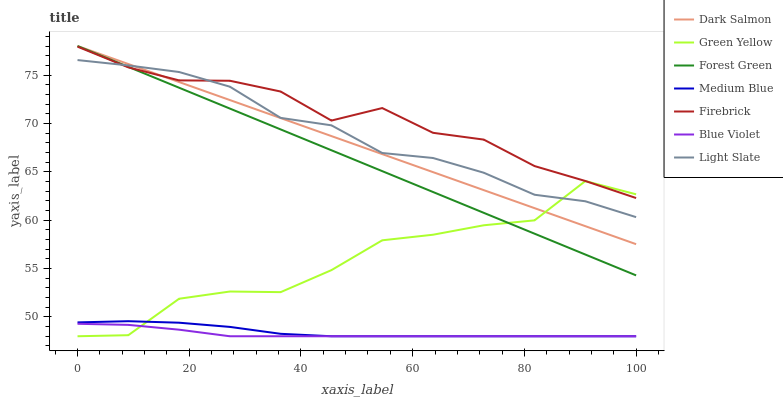Does Blue Violet have the minimum area under the curve?
Answer yes or no. Yes. Does Firebrick have the maximum area under the curve?
Answer yes or no. Yes. Does Medium Blue have the minimum area under the curve?
Answer yes or no. No. Does Medium Blue have the maximum area under the curve?
Answer yes or no. No. Is Dark Salmon the smoothest?
Answer yes or no. Yes. Is Green Yellow the roughest?
Answer yes or no. Yes. Is Firebrick the smoothest?
Answer yes or no. No. Is Firebrick the roughest?
Answer yes or no. No. Does Medium Blue have the lowest value?
Answer yes or no. Yes. Does Firebrick have the lowest value?
Answer yes or no. No. Does Forest Green have the highest value?
Answer yes or no. Yes. Does Firebrick have the highest value?
Answer yes or no. No. Is Medium Blue less than Forest Green?
Answer yes or no. Yes. Is Forest Green greater than Blue Violet?
Answer yes or no. Yes. Does Forest Green intersect Light Slate?
Answer yes or no. Yes. Is Forest Green less than Light Slate?
Answer yes or no. No. Is Forest Green greater than Light Slate?
Answer yes or no. No. Does Medium Blue intersect Forest Green?
Answer yes or no. No. 